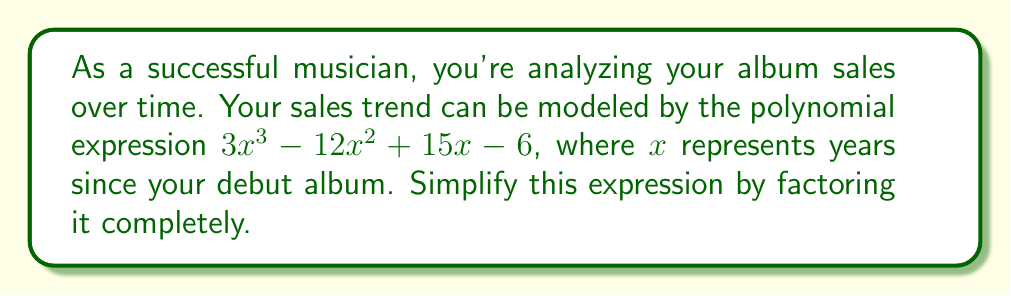Can you solve this math problem? Let's approach this step-by-step:

1) First, we can check if there's a common factor for all terms:
   $3x^3 - 12x^2 + 15x - 6$
   There's no common factor for all terms, so we move on.

2) This is a cubic expression. Let's try to factor out a linear term if possible.
   We can use the rational root theorem to find possible roots.
   The factors of the constant term (6) are: ±1, ±2, ±3, ±6
   
3) Testing these values, we find that $x = 1$ is a root.
   So $(x - 1)$ is a factor.

4) We can use polynomial long division to divide the original expression by $(x - 1)$:

   $$
   \begin{array}{r}
   3x^2 - 9x + 6 \\
   x - 1 \enclose{longdiv}{3x^3 - 12x^2 + 15x - 6} \\
      \underline{3x^3 - 3x^2} \\
      -9x^2 + 15x \\
      \underline{-9x^2 + 9x} \\
      6x - 6 \\
      \underline{6x - 6} \\
      0
   \end{array}
   $$

5) So we have: $3x^3 - 12x^2 + 15x - 6 = (x - 1)(3x^2 - 9x + 6)$

6) Now we need to factor the quadratic expression $3x^2 - 9x + 6$
   We can factor this as: $3(x^2 - 3x + 2)$
   
7) The expression inside the parentheses can be factored further:
   $x^2 - 3x + 2 = (x - 1)(x - 2)$

8) Putting it all together:
   $3x^3 - 12x^2 + 15x - 6 = (x - 1)(3x^2 - 9x + 6)$
                            $= (x - 1)(3)(x^2 - 3x + 2)$
                            $= 3(x - 1)(x - 1)(x - 2)$
                            $= 3(x - 1)^2(x - 2)$
Answer: $3(x - 1)^2(x - 2)$ 